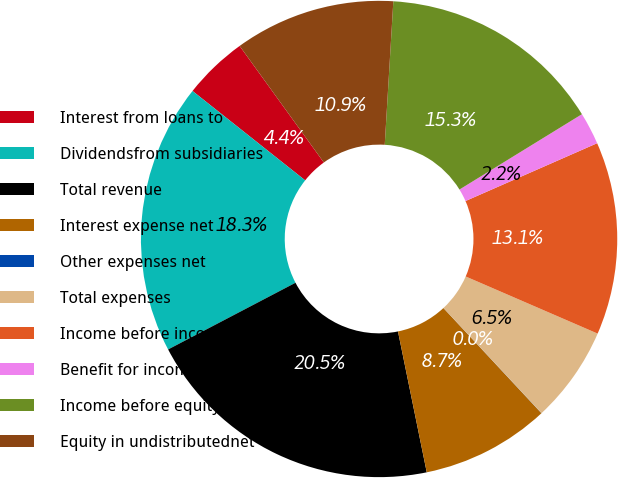<chart> <loc_0><loc_0><loc_500><loc_500><pie_chart><fcel>Interest from loans to<fcel>Dividendsfrom subsidiaries<fcel>Total revenue<fcel>Interest expense net<fcel>Other expenses net<fcel>Total expenses<fcel>Income before income taxes and<fcel>Benefit for income taxes<fcel>Income before equity in<fcel>Equity in undistributednet<nl><fcel>4.37%<fcel>18.35%<fcel>20.53%<fcel>8.73%<fcel>0.01%<fcel>6.55%<fcel>13.09%<fcel>2.19%<fcel>15.27%<fcel>10.91%<nl></chart> 